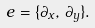Convert formula to latex. <formula><loc_0><loc_0><loc_500><loc_500>e = \{ \partial _ { x } , \, \partial _ { y } \} .</formula> 